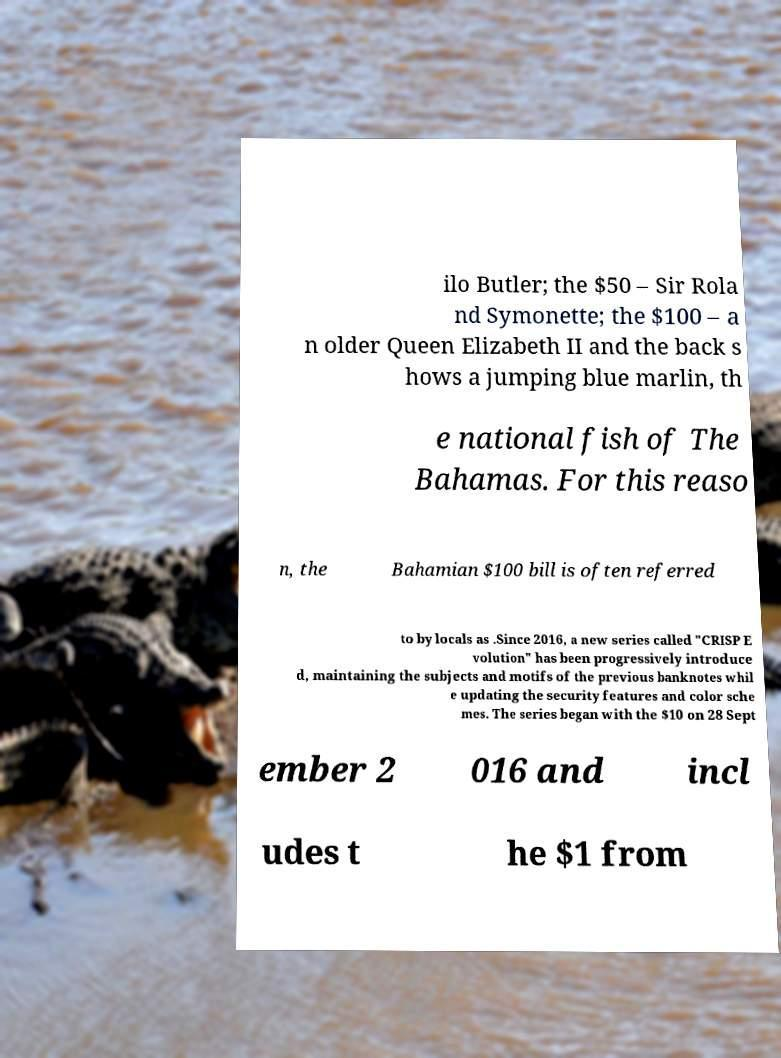For documentation purposes, I need the text within this image transcribed. Could you provide that? ilo Butler; the $50 – Sir Rola nd Symonette; the $100 – a n older Queen Elizabeth II and the back s hows a jumping blue marlin, th e national fish of The Bahamas. For this reaso n, the Bahamian $100 bill is often referred to by locals as .Since 2016, a new series called "CRISP E volution" has been progressively introduce d, maintaining the subjects and motifs of the previous banknotes whil e updating the security features and color sche mes. The series began with the $10 on 28 Sept ember 2 016 and incl udes t he $1 from 